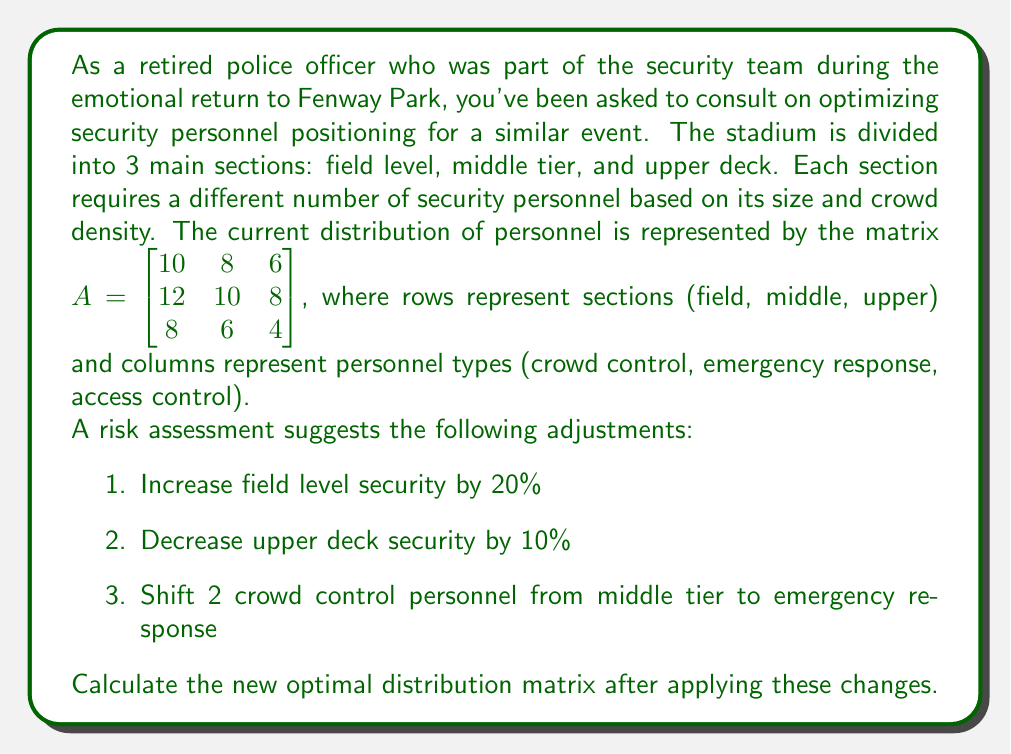Give your solution to this math problem. Let's approach this problem step-by-step:

1. First, we'll apply the percentage changes to the field level and upper deck:

   Field level (20% increase):
   $$\begin{bmatrix} 10 * 1.2 & 8 * 1.2 & 6 * 1.2 \\ 12 & 10 & 8 \\ 8 & 6 & 4 \end{bmatrix} = \begin{bmatrix} 12 & 9.6 & 7.2 \\ 12 & 10 & 8 \\ 8 & 6 & 4 \end{bmatrix}$$

   Upper deck (10% decrease):
   $$\begin{bmatrix} 12 & 9.6 & 7.2 \\ 12 & 10 & 8 \\ 8 * 0.9 & 6 * 0.9 & 4 * 0.9 \end{bmatrix} = \begin{bmatrix} 12 & 9.6 & 7.2 \\ 12 & 10 & 8 \\ 7.2 & 5.4 & 3.6 \end{bmatrix}$$

2. Now, we need to shift 2 crowd control personnel from the middle tier to emergency response:
   $$\begin{bmatrix} 12 & 9.6 & 7.2 \\ 10 & 12 & 8 \\ 7.2 & 5.4 & 3.6 \end{bmatrix}$$

3. Finally, we should round the numbers to the nearest whole number, as we can't have fractional security personnel:
   $$\begin{bmatrix} 12 & 10 & 7 \\ 10 & 12 & 8 \\ 7 & 5 & 4 \end{bmatrix}$$

This final matrix represents the new optimal distribution of security personnel across the stadium sections and roles.
Answer: The new optimal distribution matrix is:
$$\begin{bmatrix} 12 & 10 & 7 \\ 10 & 12 & 8 \\ 7 & 5 & 4 \end{bmatrix}$$ 